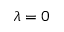<formula> <loc_0><loc_0><loc_500><loc_500>\lambda = 0</formula> 